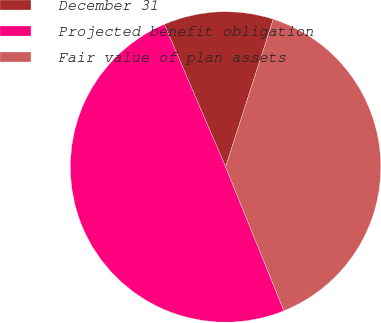Convert chart. <chart><loc_0><loc_0><loc_500><loc_500><pie_chart><fcel>December 31<fcel>Projected benefit obligation<fcel>Fair value of plan assets<nl><fcel>11.43%<fcel>49.67%<fcel>38.9%<nl></chart> 